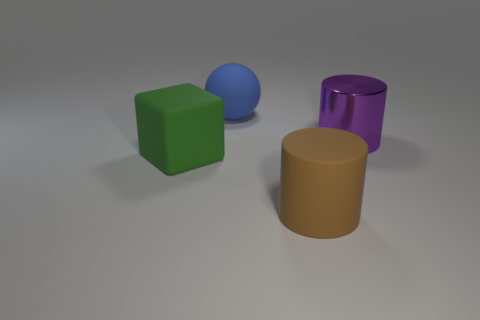Add 1 big metallic cylinders. How many objects exist? 5 Subtract all blocks. How many objects are left? 3 Add 3 shiny things. How many shiny things are left? 4 Add 2 gray rubber things. How many gray rubber things exist? 2 Subtract 0 gray balls. How many objects are left? 4 Subtract all small yellow cylinders. Subtract all large brown things. How many objects are left? 3 